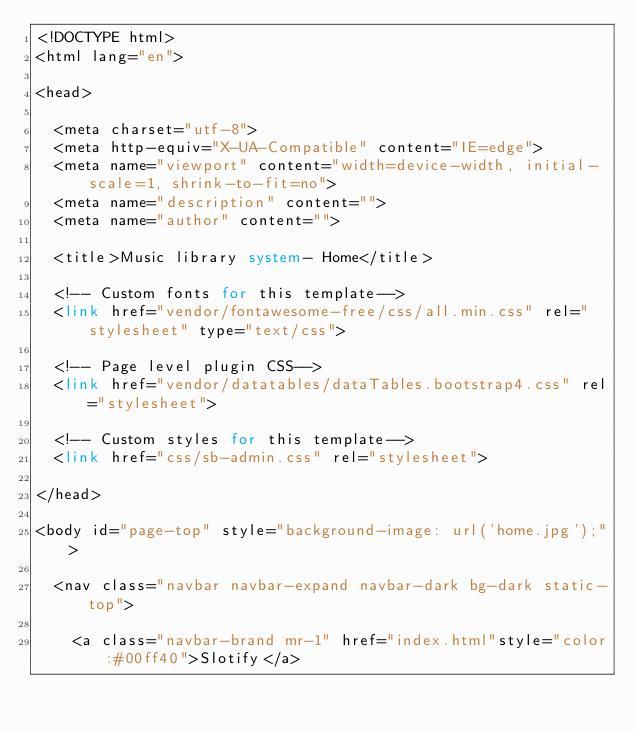<code> <loc_0><loc_0><loc_500><loc_500><_PHP_><!DOCTYPE html>
<html lang="en">

<head>

  <meta charset="utf-8">
  <meta http-equiv="X-UA-Compatible" content="IE=edge">
  <meta name="viewport" content="width=device-width, initial-scale=1, shrink-to-fit=no">
  <meta name="description" content="">
  <meta name="author" content="">

  <title>Music library system- Home</title>

  <!-- Custom fonts for this template-->
  <link href="vendor/fontawesome-free/css/all.min.css" rel="stylesheet" type="text/css">

  <!-- Page level plugin CSS-->
  <link href="vendor/datatables/dataTables.bootstrap4.css" rel="stylesheet">

  <!-- Custom styles for this template-->
  <link href="css/sb-admin.css" rel="stylesheet">

</head>

<body id="page-top" style="background-image: url('home.jpg');">

  <nav class="navbar navbar-expand navbar-dark bg-dark static-top">

    <a class="navbar-brand mr-1" href="index.html"style="color:#00ff40">Slotify</a>
</code> 